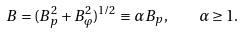Convert formula to latex. <formula><loc_0><loc_0><loc_500><loc_500>B = ( B _ { p } ^ { 2 } + B _ { \varphi } ^ { 2 } ) ^ { 1 / 2 } \equiv \alpha B _ { p } , \quad \alpha \geq 1 .</formula> 